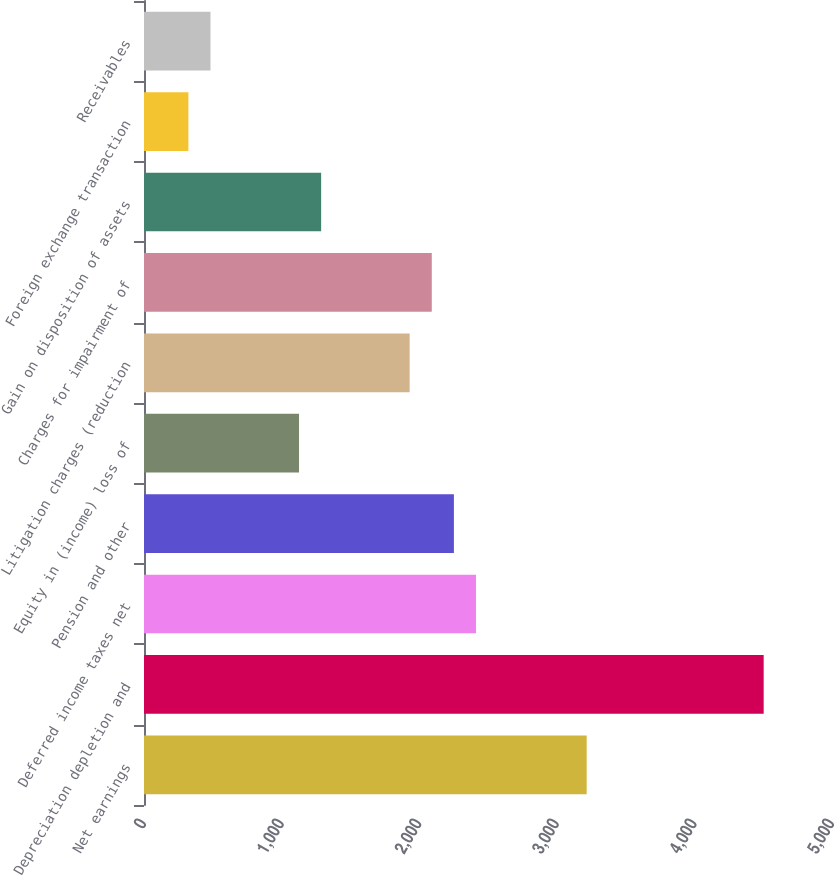<chart> <loc_0><loc_0><loc_500><loc_500><bar_chart><fcel>Net earnings<fcel>Depreciation depletion and<fcel>Deferred income taxes net<fcel>Pension and other<fcel>Equity in (income) loss of<fcel>Litigation charges (reduction<fcel>Charges for impairment of<fcel>Gain on disposition of assets<fcel>Foreign exchange transaction<fcel>Receivables<nl><fcel>3217<fcel>4503.4<fcel>2413<fcel>2252.2<fcel>1126.6<fcel>1930.6<fcel>2091.4<fcel>1287.4<fcel>322.6<fcel>483.4<nl></chart> 